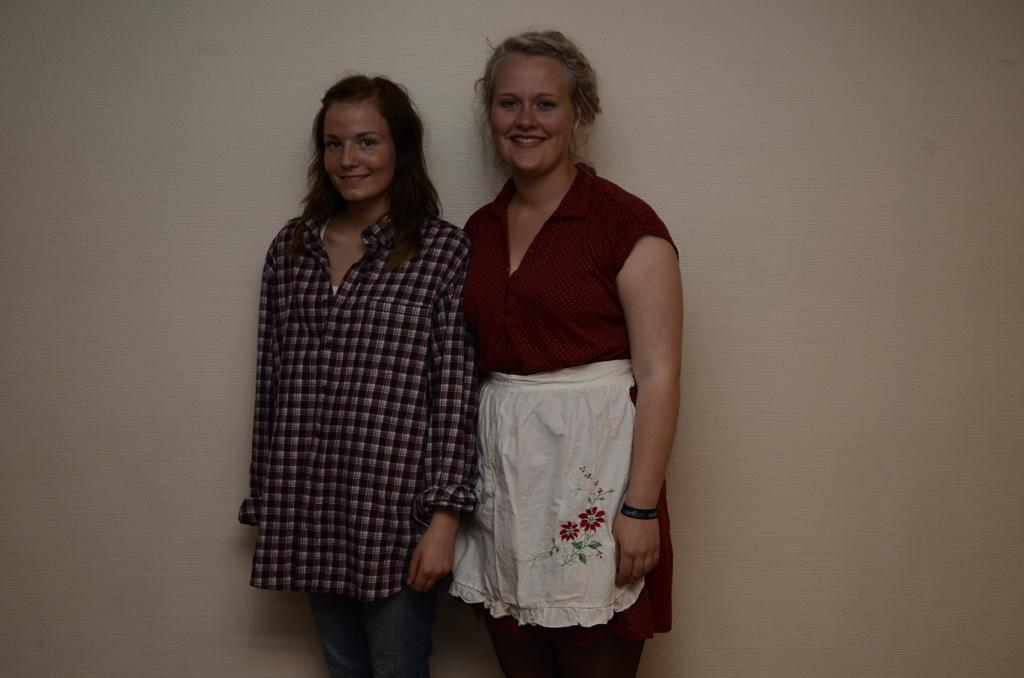Who is present in the image? There are women in the image. What is the women's position in the image? The women are standing on the floor. What type of waste is being carried by the women in the image? There is no waste present in the image; the women are not carrying anything. What type of carriage is being used by the women in the image? There is no carriage present in the image; the women are standing on the floor. 